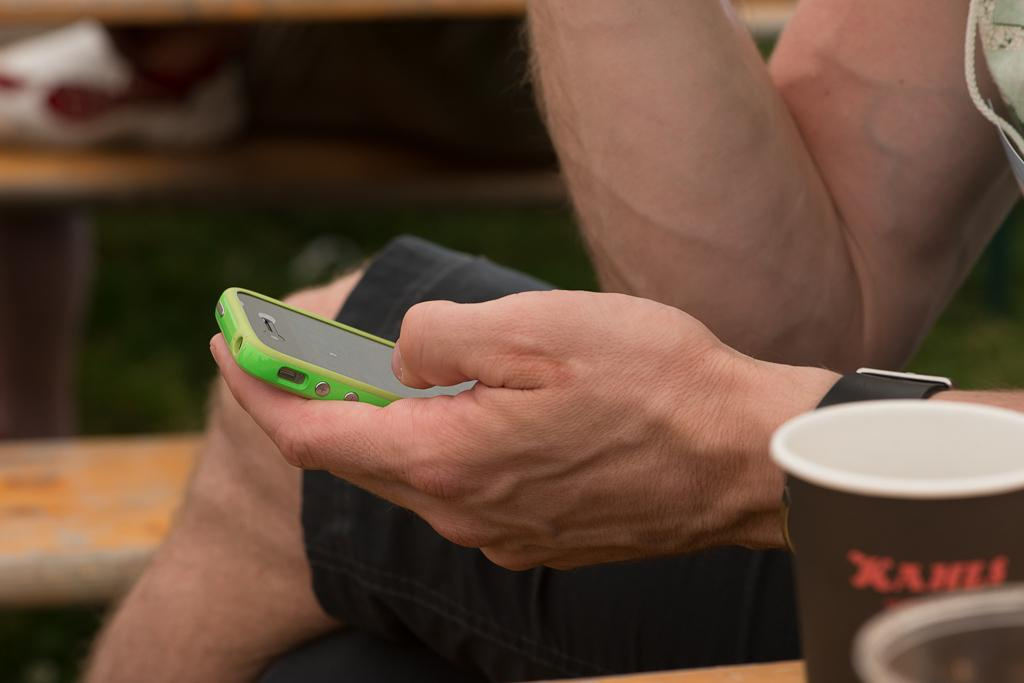Who or what is the main subject in the image? There is a person in the image. What is the person holding in the image? The person is holding a mobile. Can you describe the person's attire or accessories? The person is wearing a watch on their left hand. What is located to the left side of the person? There is a cup to the left side of the person. What is behind the person in the image? There is a table behind the person. What type of view can be seen from the boy's perspective in the image? There is no boy present in the image, and therefore no specific view can be attributed to a boy's perspective. 